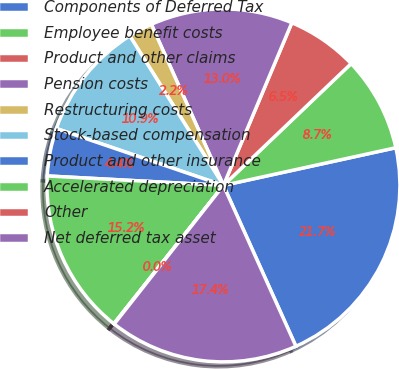Convert chart. <chart><loc_0><loc_0><loc_500><loc_500><pie_chart><fcel>Components of Deferred Tax<fcel>Employee benefit costs<fcel>Product and other claims<fcel>Pension costs<fcel>Restructuring costs<fcel>Stock-based compensation<fcel>Product and other insurance<fcel>Accelerated depreciation<fcel>Other<fcel>Net deferred tax asset<nl><fcel>21.69%<fcel>8.7%<fcel>6.54%<fcel>13.03%<fcel>2.21%<fcel>10.87%<fcel>4.37%<fcel>15.19%<fcel>0.04%<fcel>17.36%<nl></chart> 